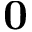Convert formula to latex. <formula><loc_0><loc_0><loc_500><loc_500>0</formula> 